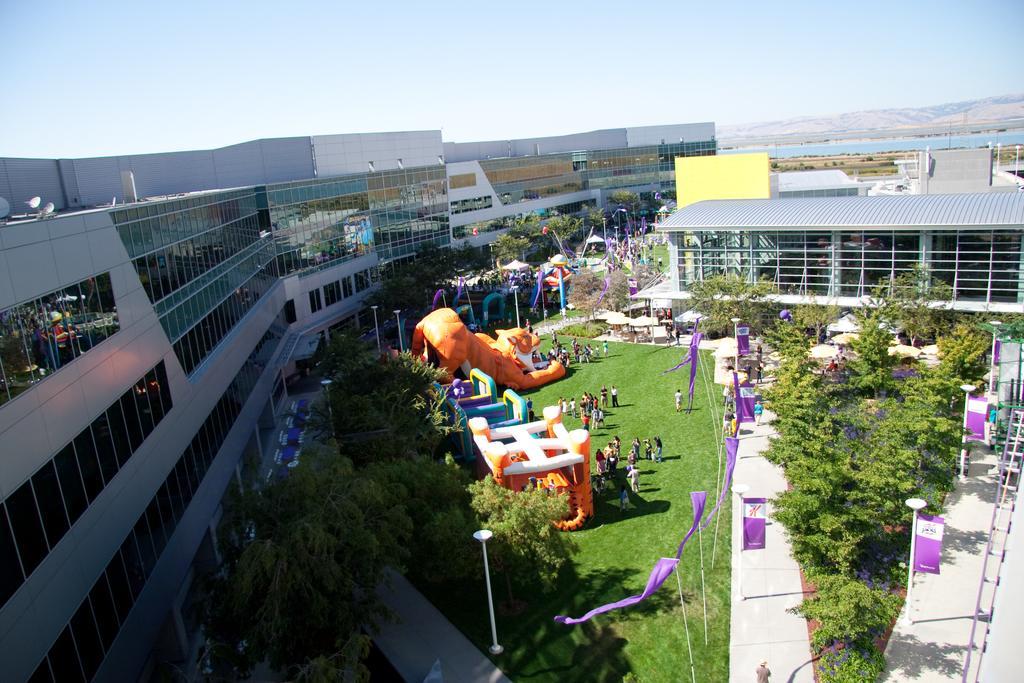In one or two sentences, can you explain what this image depicts? This image consists of buildings along with windows. At the bottom, there are trees and green grass along with the flags. In the middle, we can see a play zone. And there are few persons in this image. At the top, there is sky. 